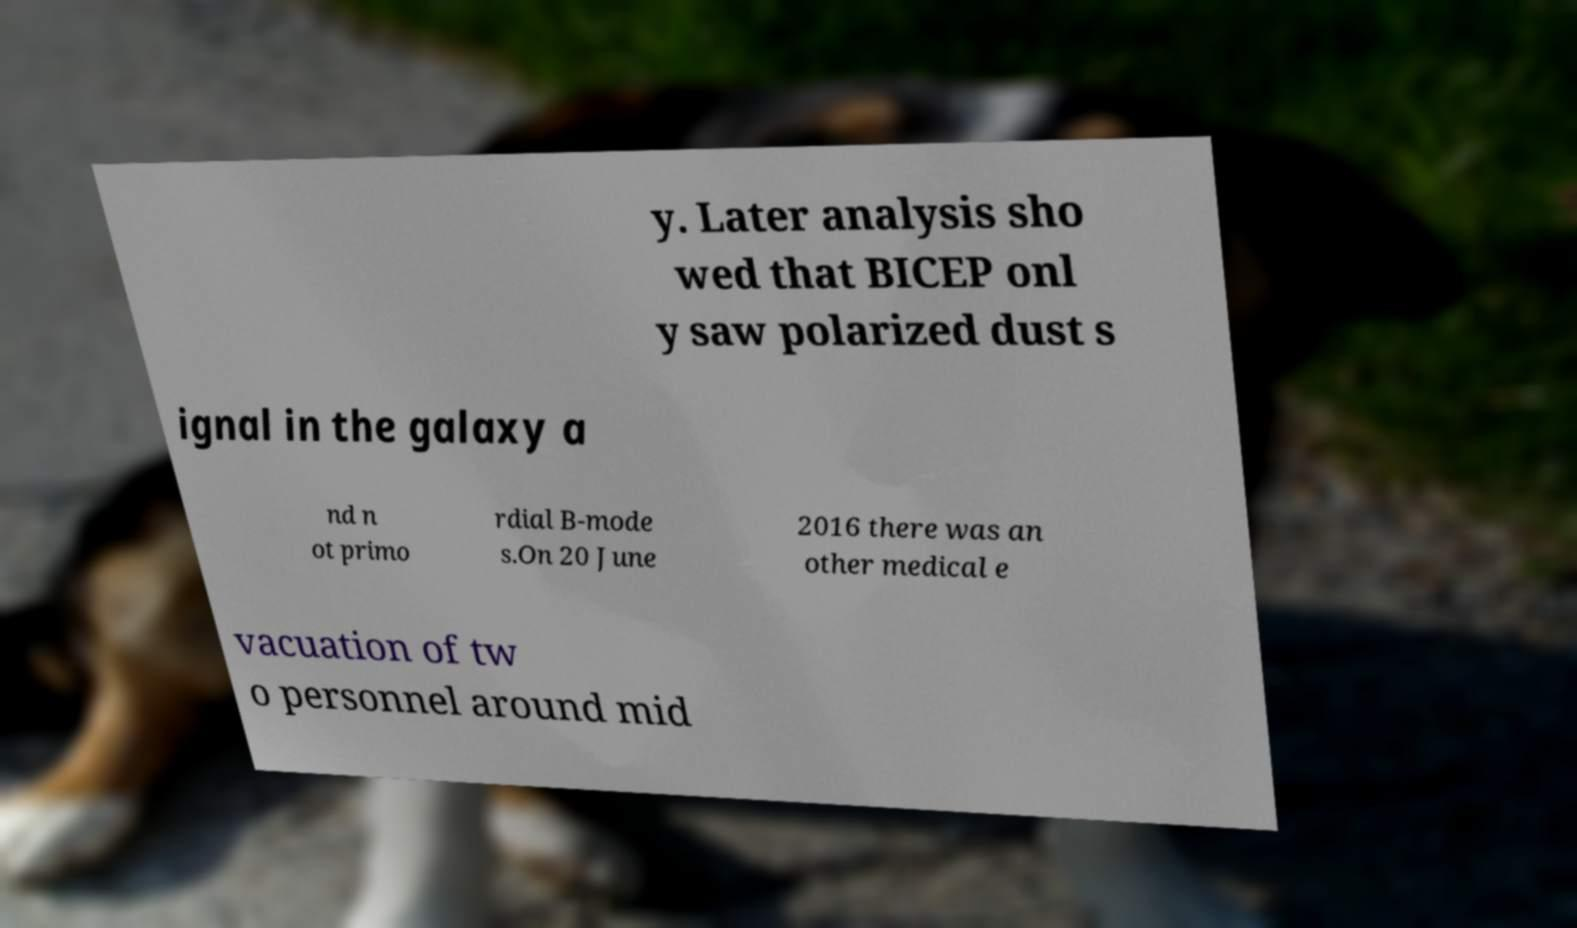There's text embedded in this image that I need extracted. Can you transcribe it verbatim? y. Later analysis sho wed that BICEP onl y saw polarized dust s ignal in the galaxy a nd n ot primo rdial B-mode s.On 20 June 2016 there was an other medical e vacuation of tw o personnel around mid 